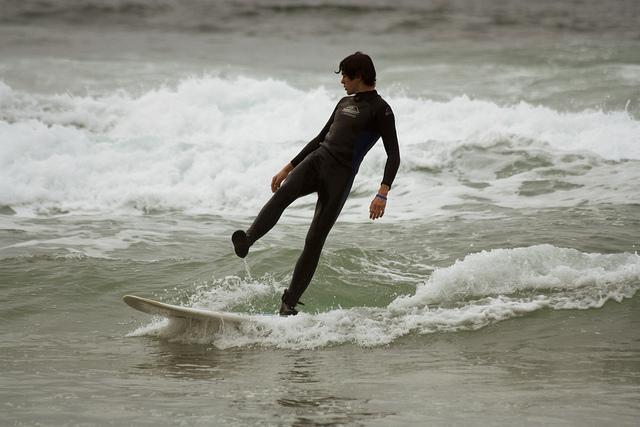How many feet are touching the board?
Give a very brief answer. 1. How many of the stuffed bears have a heart on its chest?
Give a very brief answer. 0. 